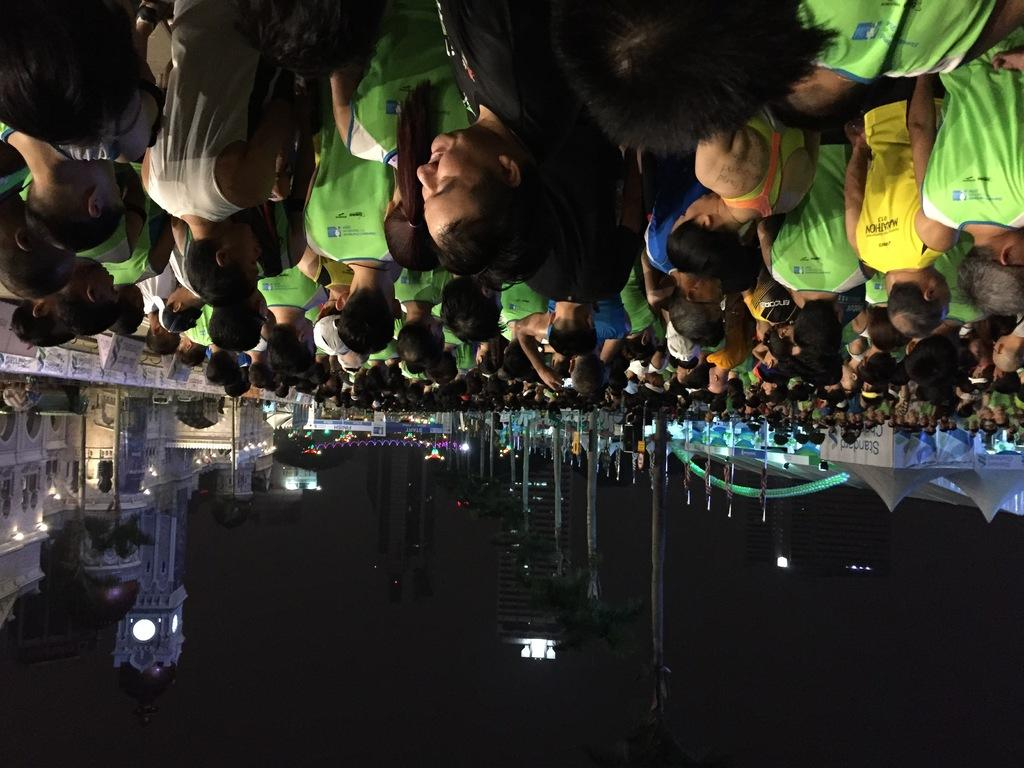What is located at the top of the image? There is a crowd of people at the top of the image. What is located at the bottom of the image? There are buildings, lights, and poles at the bottom of the image. What can be inferred about the time of day when the image was taken? The image was taken in the dark. What is the size of the belief in the image? There is no mention of a belief in the image, so it cannot be determined. What type of dinner is being served in the image? There is no dinner present in the image. 